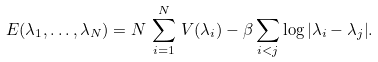Convert formula to latex. <formula><loc_0><loc_0><loc_500><loc_500>E ( \lambda _ { 1 } , \dots , \lambda _ { N } ) = N \, \sum _ { i = 1 } ^ { N } \, V ( \lambda _ { i } ) - \beta \sum _ { i < j } \log { | \lambda _ { i } - \lambda _ { j } | } .</formula> 